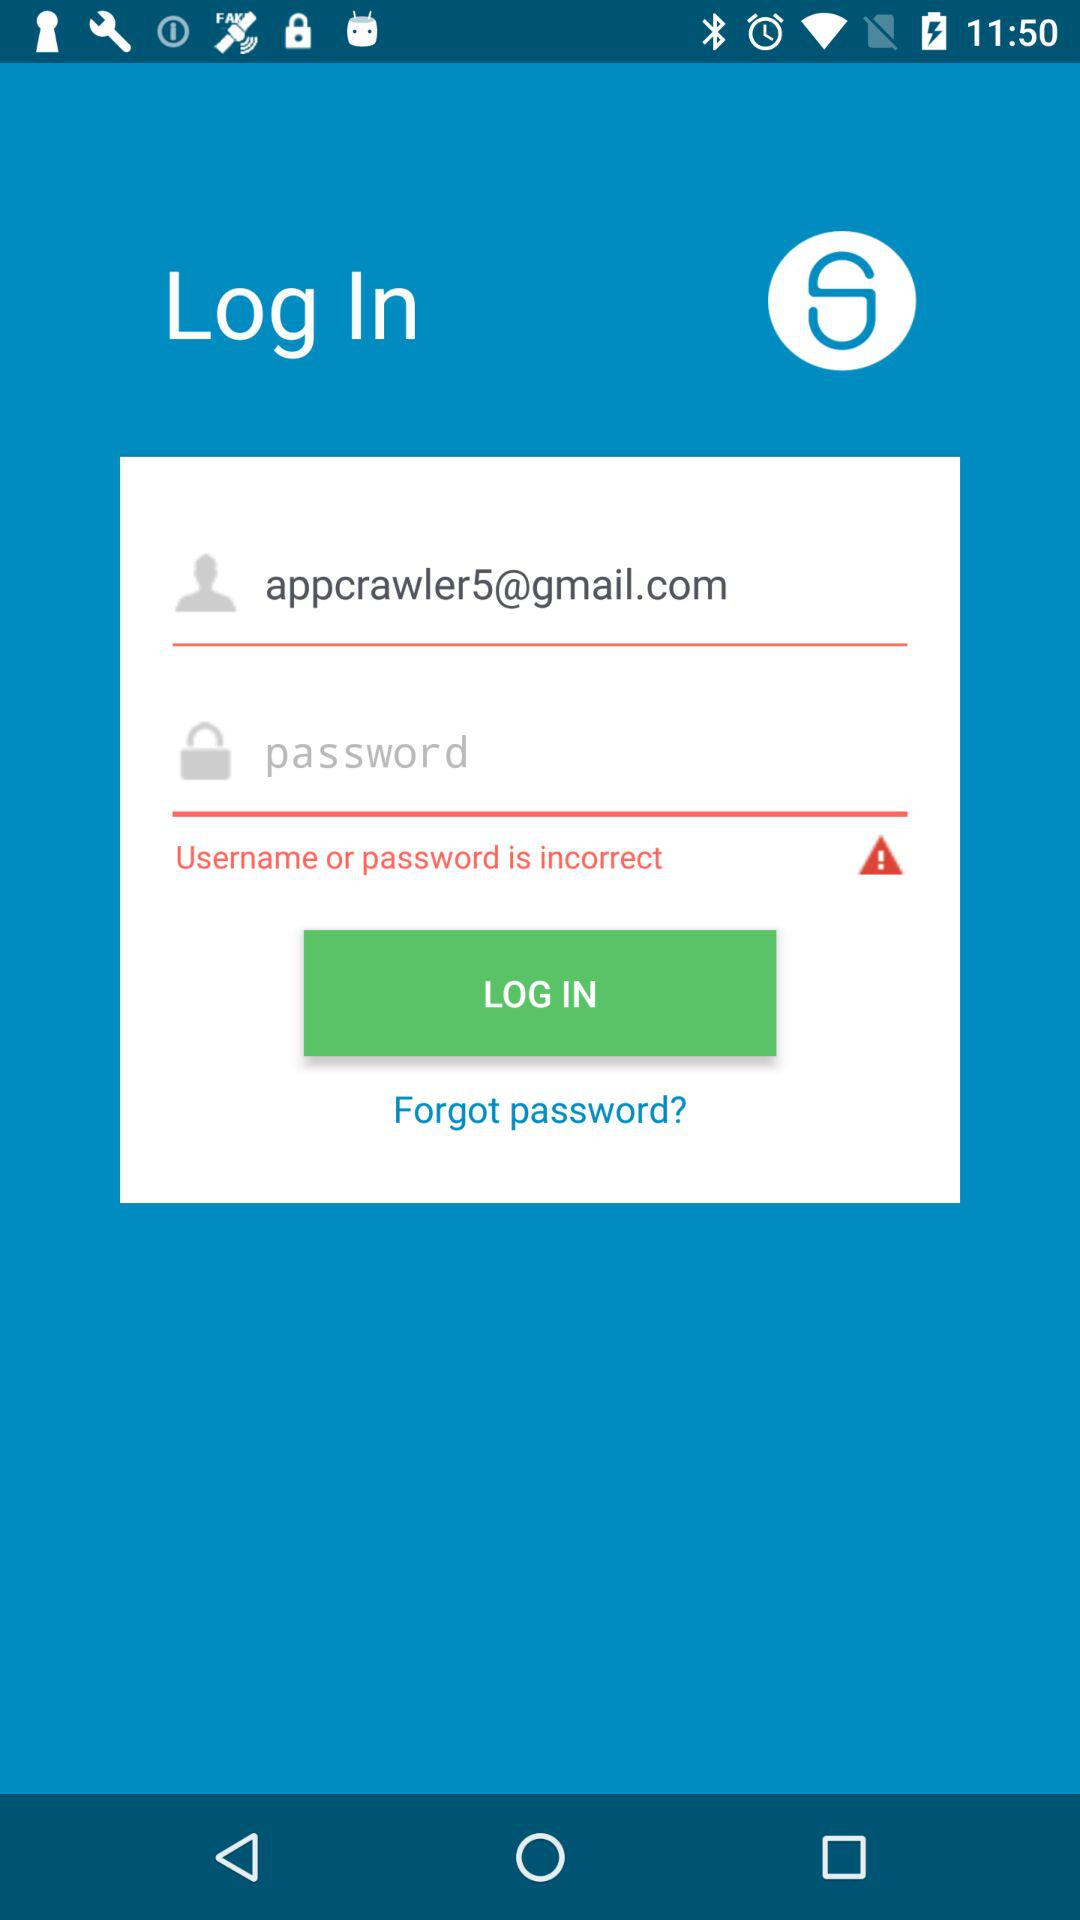What Gmail address is used to log in? The Gmail address is appcrawler5@gmail.com. 